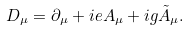<formula> <loc_0><loc_0><loc_500><loc_500>D _ { \mu } = \partial _ { \mu } + i e A _ { \mu } + i g \tilde { A } _ { \mu } .</formula> 